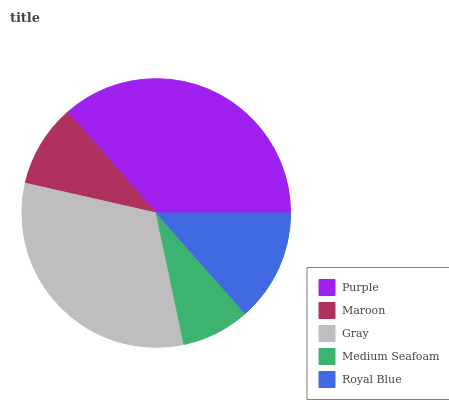Is Medium Seafoam the minimum?
Answer yes or no. Yes. Is Purple the maximum?
Answer yes or no. Yes. Is Maroon the minimum?
Answer yes or no. No. Is Maroon the maximum?
Answer yes or no. No. Is Purple greater than Maroon?
Answer yes or no. Yes. Is Maroon less than Purple?
Answer yes or no. Yes. Is Maroon greater than Purple?
Answer yes or no. No. Is Purple less than Maroon?
Answer yes or no. No. Is Royal Blue the high median?
Answer yes or no. Yes. Is Royal Blue the low median?
Answer yes or no. Yes. Is Purple the high median?
Answer yes or no. No. Is Purple the low median?
Answer yes or no. No. 